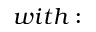<formula> <loc_0><loc_0><loc_500><loc_500>w i t h \colon</formula> 